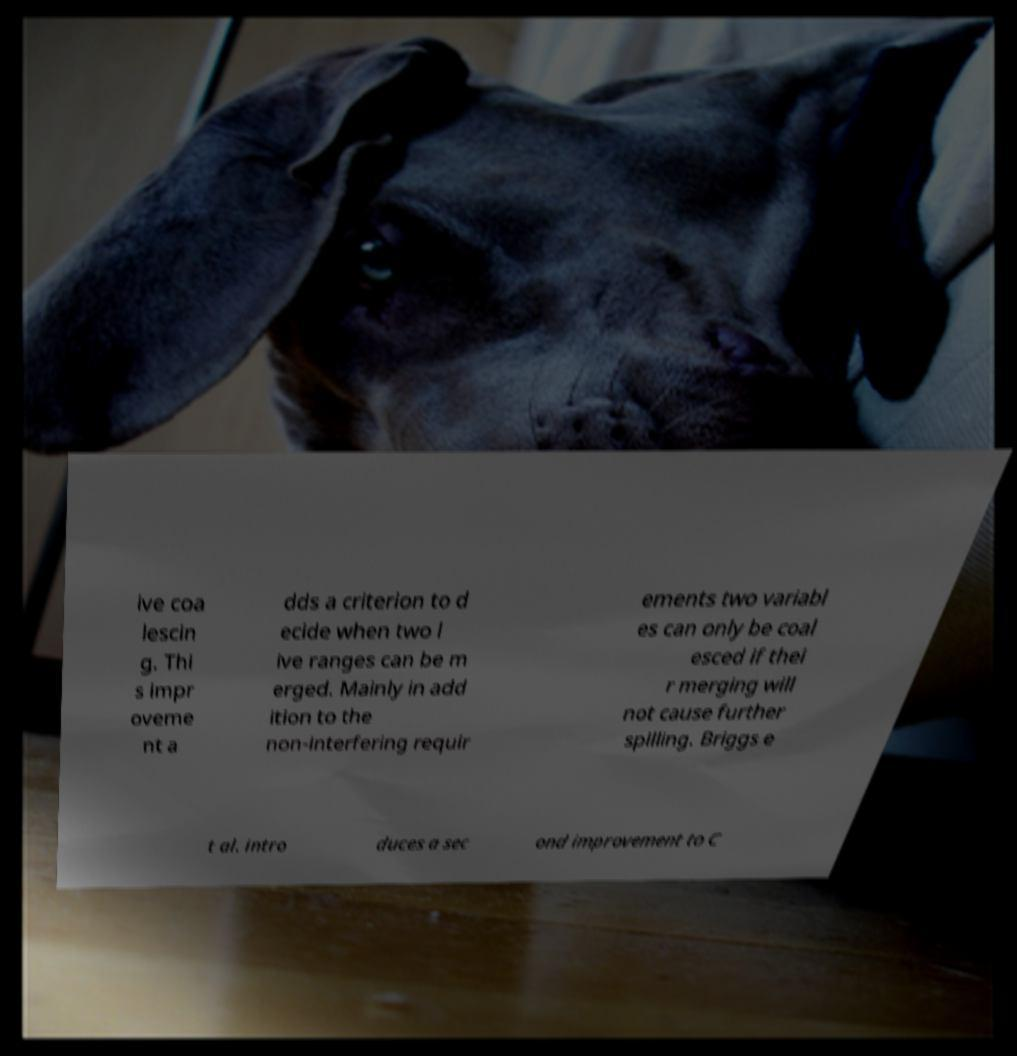There's text embedded in this image that I need extracted. Can you transcribe it verbatim? ive coa lescin g. Thi s impr oveme nt a dds a criterion to d ecide when two l ive ranges can be m erged. Mainly in add ition to the non-interfering requir ements two variabl es can only be coal esced if thei r merging will not cause further spilling. Briggs e t al. intro duces a sec ond improvement to C 